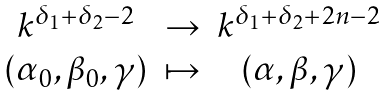<formula> <loc_0><loc_0><loc_500><loc_500>\begin{matrix} k ^ { \delta _ { 1 } + \delta _ { 2 } - 2 } & \rightarrow & k ^ { \delta _ { 1 } + \delta _ { 2 } + 2 n - 2 } \\ ( \alpha _ { 0 } , \beta _ { 0 } , \gamma ) & \mapsto & ( \alpha , \beta , \gamma ) \end{matrix}</formula> 